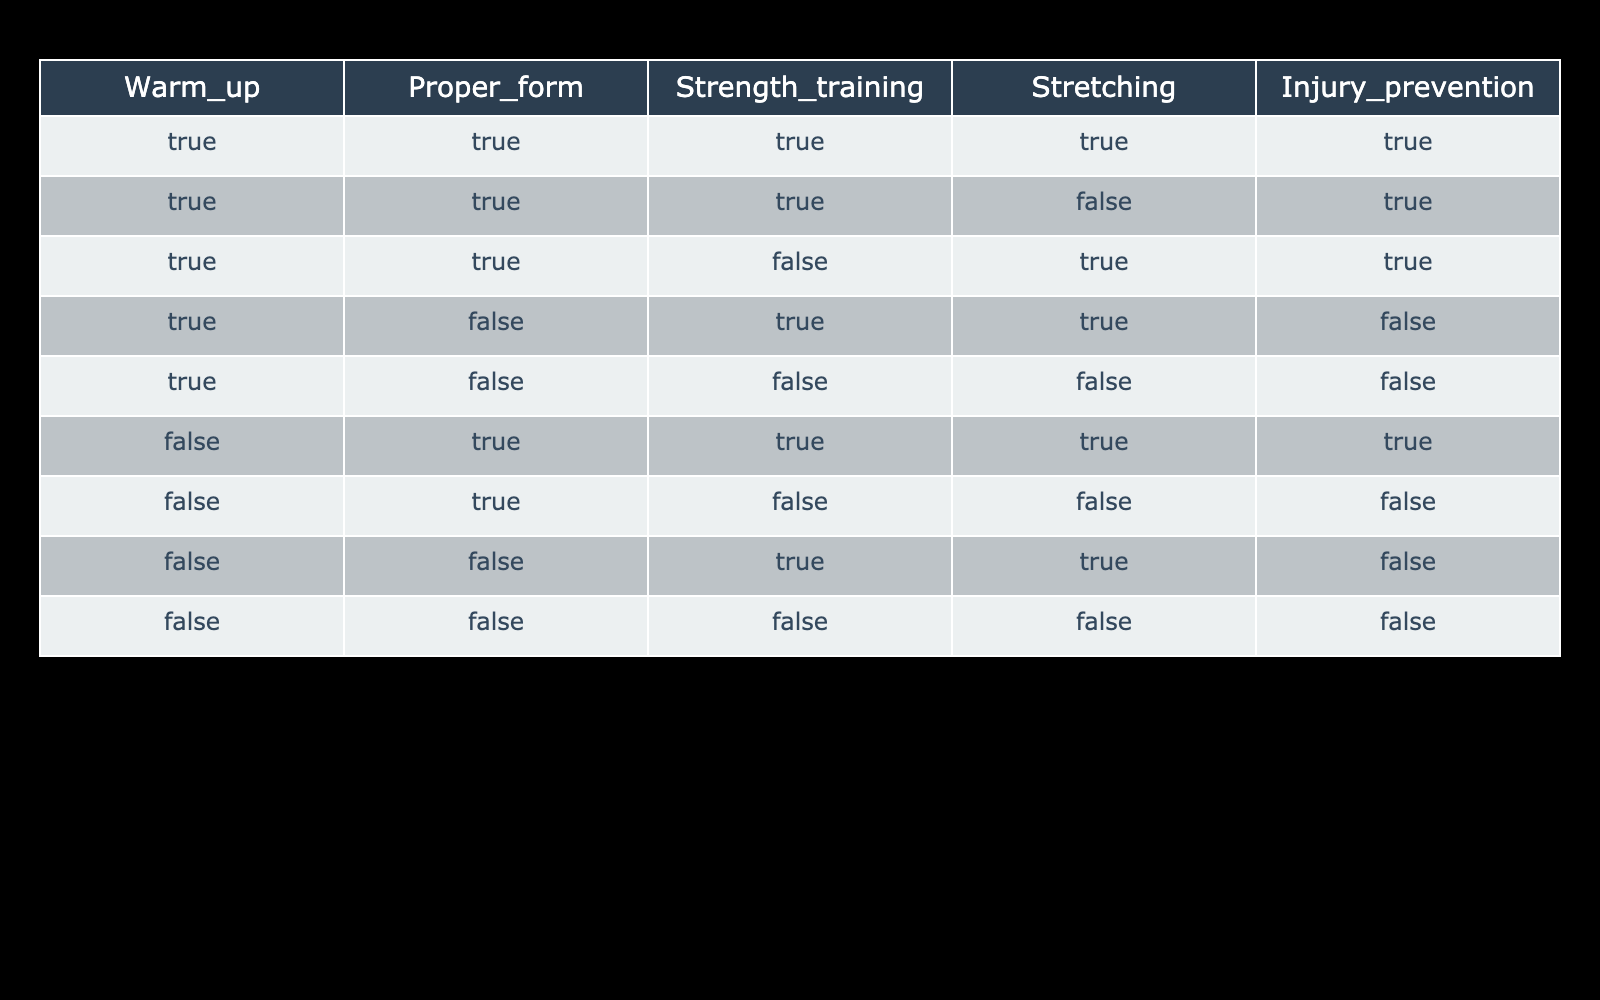What is the condition under which injury prevention is guaranteed? Injury prevention is guaranteed (TRUE) if Warm_up, Proper_form, Strength_training, and Stretching are all TRUE (the first row in the table).
Answer: TRUE How many scenarios involve Proper_form being TRUE? There are 6 scenarios (the first, second, third, sixth, and seventh rows) where Proper_form is TRUE.
Answer: 6 Is it possible to prevent injury without doing Strength_training? Injury can still be prevented without Strength_training as seen in the first, second, and sixth rows where injury prevention is TRUE despite Strength_training being FALSE.
Answer: YES How many combinations include both Warm_up and Stretching while allowing for any state of Proper_form and Strength_training? The combinations that include both Warm_up and Stretching are the first, third, and sixth rows, leading to a total of 3 combinations.
Answer: 3 In how many scenarios is injury prevention not achieved? Injury prevention is not achieved in the fourth, fifth, seventh, eighth rows, totaling 4 scenarios where injury prevention is FALSE.
Answer: 4 How would you summarize the scenarios with warm-up exercises in terms of injury prevention? The injury prevention is guaranteed in 3 out of 5 scenarios with Warm_up (the first, second, and third rows), it is only false in two scenarios (the fourth and fifth).
Answer: 3 out of 5 Is there a scenario where all exercises are FALSE but still allows for injury prevention? There is no scenario where all exercises are FALSE (the eighth row) and injury prevention is TRUE. The only row with all FALSEs shows injury prevention is FALSE.
Answer: NO How many total injury prevention scenarios are there when Stretching is performed? Injury prevention occurs in the scenarios where Stretching is TRUE (in first, second, third, and sixth rows) leading to a total of 4 scenarios.
Answer: 4 What is the outcome when both Warm_up and Proper_form are FALSE? When both Warm_up and Proper_form are FALSE, injury prevention is achieved only if Strength_training and Stretching are both TRUE, which happens in the seventh row, resulting in injury prevention being FALSE.
Answer: FALSE 